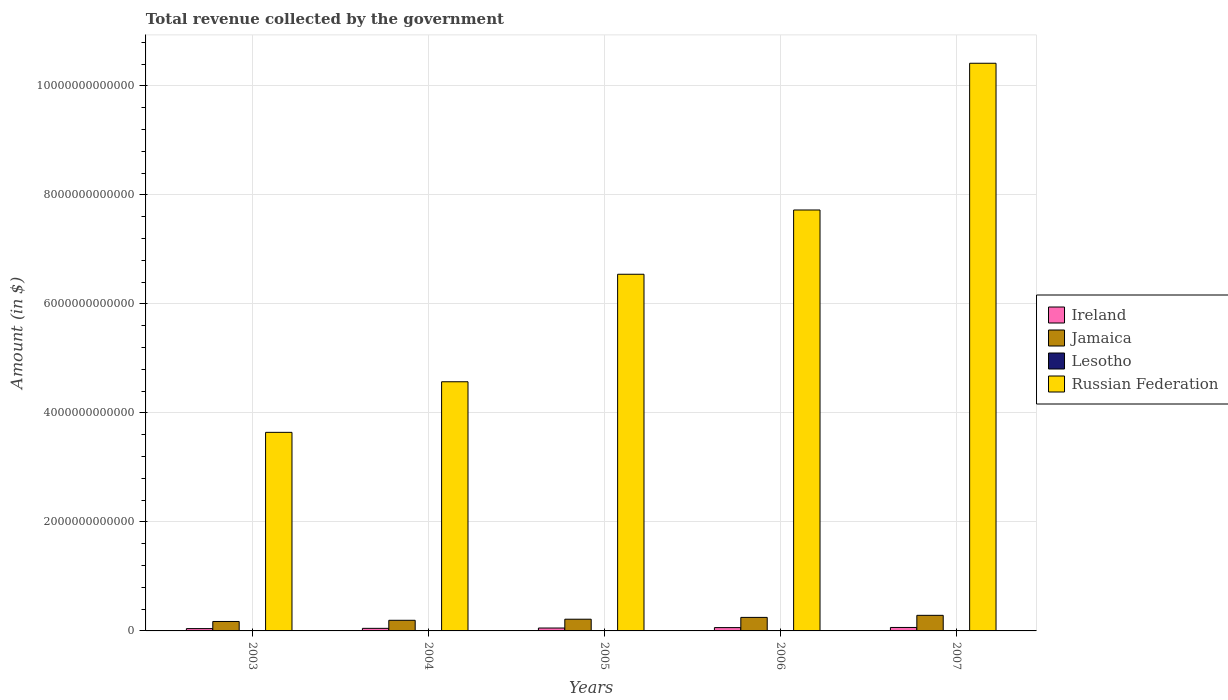How many groups of bars are there?
Your response must be concise. 5. Are the number of bars per tick equal to the number of legend labels?
Make the answer very short. Yes. How many bars are there on the 2nd tick from the left?
Offer a terse response. 4. How many bars are there on the 2nd tick from the right?
Provide a succinct answer. 4. In how many cases, is the number of bars for a given year not equal to the number of legend labels?
Offer a very short reply. 0. What is the total revenue collected by the government in Lesotho in 2003?
Make the answer very short. 3.47e+09. Across all years, what is the maximum total revenue collected by the government in Lesotho?
Ensure brevity in your answer.  7.13e+09. Across all years, what is the minimum total revenue collected by the government in Ireland?
Your answer should be compact. 4.25e+1. In which year was the total revenue collected by the government in Lesotho minimum?
Your answer should be very brief. 2003. What is the total total revenue collected by the government in Lesotho in the graph?
Provide a succinct answer. 2.59e+1. What is the difference between the total revenue collected by the government in Lesotho in 2005 and that in 2006?
Make the answer very short. -1.95e+09. What is the difference between the total revenue collected by the government in Lesotho in 2007 and the total revenue collected by the government in Jamaica in 2003?
Your answer should be compact. -1.66e+11. What is the average total revenue collected by the government in Russian Federation per year?
Make the answer very short. 6.58e+12. In the year 2006, what is the difference between the total revenue collected by the government in Jamaica and total revenue collected by the government in Russian Federation?
Provide a short and direct response. -7.48e+12. In how many years, is the total revenue collected by the government in Lesotho greater than 400000000000 $?
Keep it short and to the point. 0. What is the ratio of the total revenue collected by the government in Lesotho in 2005 to that in 2006?
Make the answer very short. 0.7. Is the difference between the total revenue collected by the government in Jamaica in 2005 and 2006 greater than the difference between the total revenue collected by the government in Russian Federation in 2005 and 2006?
Your response must be concise. Yes. What is the difference between the highest and the second highest total revenue collected by the government in Lesotho?
Offer a very short reply. 6.38e+08. What is the difference between the highest and the lowest total revenue collected by the government in Ireland?
Your response must be concise. 2.11e+1. In how many years, is the total revenue collected by the government in Jamaica greater than the average total revenue collected by the government in Jamaica taken over all years?
Your answer should be compact. 2. What does the 1st bar from the left in 2003 represents?
Offer a very short reply. Ireland. What does the 2nd bar from the right in 2005 represents?
Your answer should be very brief. Lesotho. How many bars are there?
Provide a short and direct response. 20. What is the difference between two consecutive major ticks on the Y-axis?
Give a very brief answer. 2.00e+12. Does the graph contain any zero values?
Offer a very short reply. No. Does the graph contain grids?
Your answer should be very brief. Yes. How many legend labels are there?
Provide a succinct answer. 4. What is the title of the graph?
Offer a very short reply. Total revenue collected by the government. Does "Myanmar" appear as one of the legend labels in the graph?
Offer a very short reply. No. What is the label or title of the Y-axis?
Offer a very short reply. Amount (in $). What is the Amount (in $) in Ireland in 2003?
Make the answer very short. 4.25e+1. What is the Amount (in $) in Jamaica in 2003?
Ensure brevity in your answer.  1.73e+11. What is the Amount (in $) in Lesotho in 2003?
Your response must be concise. 3.47e+09. What is the Amount (in $) of Russian Federation in 2003?
Your answer should be compact. 3.64e+12. What is the Amount (in $) of Ireland in 2004?
Your answer should be compact. 4.73e+1. What is the Amount (in $) of Jamaica in 2004?
Ensure brevity in your answer.  1.95e+11. What is the Amount (in $) in Lesotho in 2004?
Provide a short and direct response. 4.25e+09. What is the Amount (in $) of Russian Federation in 2004?
Provide a short and direct response. 4.57e+12. What is the Amount (in $) of Ireland in 2005?
Ensure brevity in your answer.  5.32e+1. What is the Amount (in $) of Jamaica in 2005?
Your answer should be very brief. 2.15e+11. What is the Amount (in $) of Lesotho in 2005?
Offer a very short reply. 4.53e+09. What is the Amount (in $) of Russian Federation in 2005?
Offer a very short reply. 6.54e+12. What is the Amount (in $) in Ireland in 2006?
Provide a succinct answer. 6.09e+1. What is the Amount (in $) of Jamaica in 2006?
Your answer should be very brief. 2.48e+11. What is the Amount (in $) in Lesotho in 2006?
Your answer should be compact. 6.49e+09. What is the Amount (in $) in Russian Federation in 2006?
Provide a succinct answer. 7.72e+12. What is the Amount (in $) in Ireland in 2007?
Keep it short and to the point. 6.36e+1. What is the Amount (in $) in Jamaica in 2007?
Make the answer very short. 2.86e+11. What is the Amount (in $) of Lesotho in 2007?
Offer a very short reply. 7.13e+09. What is the Amount (in $) of Russian Federation in 2007?
Keep it short and to the point. 1.04e+13. Across all years, what is the maximum Amount (in $) in Ireland?
Your response must be concise. 6.36e+1. Across all years, what is the maximum Amount (in $) in Jamaica?
Keep it short and to the point. 2.86e+11. Across all years, what is the maximum Amount (in $) in Lesotho?
Ensure brevity in your answer.  7.13e+09. Across all years, what is the maximum Amount (in $) of Russian Federation?
Provide a short and direct response. 1.04e+13. Across all years, what is the minimum Amount (in $) in Ireland?
Offer a very short reply. 4.25e+1. Across all years, what is the minimum Amount (in $) in Jamaica?
Give a very brief answer. 1.73e+11. Across all years, what is the minimum Amount (in $) in Lesotho?
Ensure brevity in your answer.  3.47e+09. Across all years, what is the minimum Amount (in $) in Russian Federation?
Provide a succinct answer. 3.64e+12. What is the total Amount (in $) of Ireland in the graph?
Give a very brief answer. 2.67e+11. What is the total Amount (in $) of Jamaica in the graph?
Your response must be concise. 1.12e+12. What is the total Amount (in $) in Lesotho in the graph?
Offer a terse response. 2.59e+1. What is the total Amount (in $) in Russian Federation in the graph?
Your answer should be compact. 3.29e+13. What is the difference between the Amount (in $) in Ireland in 2003 and that in 2004?
Offer a terse response. -4.79e+09. What is the difference between the Amount (in $) in Jamaica in 2003 and that in 2004?
Give a very brief answer. -2.19e+1. What is the difference between the Amount (in $) in Lesotho in 2003 and that in 2004?
Offer a terse response. -7.84e+08. What is the difference between the Amount (in $) of Russian Federation in 2003 and that in 2004?
Provide a succinct answer. -9.28e+11. What is the difference between the Amount (in $) in Ireland in 2003 and that in 2005?
Provide a succinct answer. -1.07e+1. What is the difference between the Amount (in $) in Jamaica in 2003 and that in 2005?
Your response must be concise. -4.17e+1. What is the difference between the Amount (in $) in Lesotho in 2003 and that in 2005?
Your response must be concise. -1.07e+09. What is the difference between the Amount (in $) of Russian Federation in 2003 and that in 2005?
Offer a terse response. -2.90e+12. What is the difference between the Amount (in $) in Ireland in 2003 and that in 2006?
Offer a very short reply. -1.84e+1. What is the difference between the Amount (in $) of Jamaica in 2003 and that in 2006?
Offer a very short reply. -7.50e+1. What is the difference between the Amount (in $) in Lesotho in 2003 and that in 2006?
Make the answer very short. -3.02e+09. What is the difference between the Amount (in $) in Russian Federation in 2003 and that in 2006?
Give a very brief answer. -4.08e+12. What is the difference between the Amount (in $) in Ireland in 2003 and that in 2007?
Your answer should be very brief. -2.11e+1. What is the difference between the Amount (in $) of Jamaica in 2003 and that in 2007?
Ensure brevity in your answer.  -1.13e+11. What is the difference between the Amount (in $) of Lesotho in 2003 and that in 2007?
Provide a succinct answer. -3.66e+09. What is the difference between the Amount (in $) of Russian Federation in 2003 and that in 2007?
Give a very brief answer. -6.77e+12. What is the difference between the Amount (in $) of Ireland in 2004 and that in 2005?
Ensure brevity in your answer.  -5.94e+09. What is the difference between the Amount (in $) of Jamaica in 2004 and that in 2005?
Provide a succinct answer. -1.99e+1. What is the difference between the Amount (in $) of Lesotho in 2004 and that in 2005?
Offer a terse response. -2.81e+08. What is the difference between the Amount (in $) in Russian Federation in 2004 and that in 2005?
Offer a terse response. -1.97e+12. What is the difference between the Amount (in $) of Ireland in 2004 and that in 2006?
Provide a short and direct response. -1.36e+1. What is the difference between the Amount (in $) in Jamaica in 2004 and that in 2006?
Your answer should be very brief. -5.32e+1. What is the difference between the Amount (in $) in Lesotho in 2004 and that in 2006?
Your answer should be compact. -2.23e+09. What is the difference between the Amount (in $) in Russian Federation in 2004 and that in 2006?
Provide a succinct answer. -3.15e+12. What is the difference between the Amount (in $) in Ireland in 2004 and that in 2007?
Provide a short and direct response. -1.63e+1. What is the difference between the Amount (in $) of Jamaica in 2004 and that in 2007?
Your response must be concise. -9.10e+1. What is the difference between the Amount (in $) of Lesotho in 2004 and that in 2007?
Make the answer very short. -2.87e+09. What is the difference between the Amount (in $) of Russian Federation in 2004 and that in 2007?
Give a very brief answer. -5.84e+12. What is the difference between the Amount (in $) in Ireland in 2005 and that in 2006?
Ensure brevity in your answer.  -7.67e+09. What is the difference between the Amount (in $) in Jamaica in 2005 and that in 2006?
Offer a very short reply. -3.33e+1. What is the difference between the Amount (in $) of Lesotho in 2005 and that in 2006?
Your response must be concise. -1.95e+09. What is the difference between the Amount (in $) in Russian Federation in 2005 and that in 2006?
Provide a short and direct response. -1.18e+12. What is the difference between the Amount (in $) of Ireland in 2005 and that in 2007?
Offer a very short reply. -1.04e+1. What is the difference between the Amount (in $) in Jamaica in 2005 and that in 2007?
Ensure brevity in your answer.  -7.11e+1. What is the difference between the Amount (in $) in Lesotho in 2005 and that in 2007?
Provide a short and direct response. -2.59e+09. What is the difference between the Amount (in $) in Russian Federation in 2005 and that in 2007?
Give a very brief answer. -3.87e+12. What is the difference between the Amount (in $) of Ireland in 2006 and that in 2007?
Your response must be concise. -2.70e+09. What is the difference between the Amount (in $) in Jamaica in 2006 and that in 2007?
Keep it short and to the point. -3.78e+1. What is the difference between the Amount (in $) in Lesotho in 2006 and that in 2007?
Make the answer very short. -6.38e+08. What is the difference between the Amount (in $) in Russian Federation in 2006 and that in 2007?
Your answer should be compact. -2.69e+12. What is the difference between the Amount (in $) of Ireland in 2003 and the Amount (in $) of Jamaica in 2004?
Offer a terse response. -1.53e+11. What is the difference between the Amount (in $) in Ireland in 2003 and the Amount (in $) in Lesotho in 2004?
Offer a very short reply. 3.82e+1. What is the difference between the Amount (in $) of Ireland in 2003 and the Amount (in $) of Russian Federation in 2004?
Make the answer very short. -4.53e+12. What is the difference between the Amount (in $) of Jamaica in 2003 and the Amount (in $) of Lesotho in 2004?
Your answer should be compact. 1.69e+11. What is the difference between the Amount (in $) in Jamaica in 2003 and the Amount (in $) in Russian Federation in 2004?
Keep it short and to the point. -4.40e+12. What is the difference between the Amount (in $) in Lesotho in 2003 and the Amount (in $) in Russian Federation in 2004?
Give a very brief answer. -4.57e+12. What is the difference between the Amount (in $) in Ireland in 2003 and the Amount (in $) in Jamaica in 2005?
Your response must be concise. -1.72e+11. What is the difference between the Amount (in $) of Ireland in 2003 and the Amount (in $) of Lesotho in 2005?
Keep it short and to the point. 3.79e+1. What is the difference between the Amount (in $) in Ireland in 2003 and the Amount (in $) in Russian Federation in 2005?
Give a very brief answer. -6.50e+12. What is the difference between the Amount (in $) in Jamaica in 2003 and the Amount (in $) in Lesotho in 2005?
Provide a succinct answer. 1.69e+11. What is the difference between the Amount (in $) in Jamaica in 2003 and the Amount (in $) in Russian Federation in 2005?
Your answer should be very brief. -6.37e+12. What is the difference between the Amount (in $) of Lesotho in 2003 and the Amount (in $) of Russian Federation in 2005?
Provide a short and direct response. -6.54e+12. What is the difference between the Amount (in $) of Ireland in 2003 and the Amount (in $) of Jamaica in 2006?
Provide a short and direct response. -2.06e+11. What is the difference between the Amount (in $) of Ireland in 2003 and the Amount (in $) of Lesotho in 2006?
Give a very brief answer. 3.60e+1. What is the difference between the Amount (in $) in Ireland in 2003 and the Amount (in $) in Russian Federation in 2006?
Your answer should be very brief. -7.68e+12. What is the difference between the Amount (in $) in Jamaica in 2003 and the Amount (in $) in Lesotho in 2006?
Give a very brief answer. 1.67e+11. What is the difference between the Amount (in $) in Jamaica in 2003 and the Amount (in $) in Russian Federation in 2006?
Provide a succinct answer. -7.55e+12. What is the difference between the Amount (in $) of Lesotho in 2003 and the Amount (in $) of Russian Federation in 2006?
Make the answer very short. -7.72e+12. What is the difference between the Amount (in $) in Ireland in 2003 and the Amount (in $) in Jamaica in 2007?
Your answer should be very brief. -2.44e+11. What is the difference between the Amount (in $) in Ireland in 2003 and the Amount (in $) in Lesotho in 2007?
Give a very brief answer. 3.53e+1. What is the difference between the Amount (in $) in Ireland in 2003 and the Amount (in $) in Russian Federation in 2007?
Offer a very short reply. -1.04e+13. What is the difference between the Amount (in $) in Jamaica in 2003 and the Amount (in $) in Lesotho in 2007?
Provide a short and direct response. 1.66e+11. What is the difference between the Amount (in $) in Jamaica in 2003 and the Amount (in $) in Russian Federation in 2007?
Provide a succinct answer. -1.02e+13. What is the difference between the Amount (in $) of Lesotho in 2003 and the Amount (in $) of Russian Federation in 2007?
Your answer should be very brief. -1.04e+13. What is the difference between the Amount (in $) in Ireland in 2004 and the Amount (in $) in Jamaica in 2005?
Provide a short and direct response. -1.68e+11. What is the difference between the Amount (in $) in Ireland in 2004 and the Amount (in $) in Lesotho in 2005?
Provide a short and direct response. 4.27e+1. What is the difference between the Amount (in $) of Ireland in 2004 and the Amount (in $) of Russian Federation in 2005?
Make the answer very short. -6.50e+12. What is the difference between the Amount (in $) in Jamaica in 2004 and the Amount (in $) in Lesotho in 2005?
Provide a short and direct response. 1.91e+11. What is the difference between the Amount (in $) of Jamaica in 2004 and the Amount (in $) of Russian Federation in 2005?
Your answer should be compact. -6.35e+12. What is the difference between the Amount (in $) in Lesotho in 2004 and the Amount (in $) in Russian Federation in 2005?
Offer a terse response. -6.54e+12. What is the difference between the Amount (in $) in Ireland in 2004 and the Amount (in $) in Jamaica in 2006?
Give a very brief answer. -2.01e+11. What is the difference between the Amount (in $) of Ireland in 2004 and the Amount (in $) of Lesotho in 2006?
Your answer should be compact. 4.08e+1. What is the difference between the Amount (in $) of Ireland in 2004 and the Amount (in $) of Russian Federation in 2006?
Make the answer very short. -7.68e+12. What is the difference between the Amount (in $) in Jamaica in 2004 and the Amount (in $) in Lesotho in 2006?
Provide a succinct answer. 1.89e+11. What is the difference between the Amount (in $) in Jamaica in 2004 and the Amount (in $) in Russian Federation in 2006?
Ensure brevity in your answer.  -7.53e+12. What is the difference between the Amount (in $) of Lesotho in 2004 and the Amount (in $) of Russian Federation in 2006?
Provide a short and direct response. -7.72e+12. What is the difference between the Amount (in $) of Ireland in 2004 and the Amount (in $) of Jamaica in 2007?
Keep it short and to the point. -2.39e+11. What is the difference between the Amount (in $) of Ireland in 2004 and the Amount (in $) of Lesotho in 2007?
Provide a succinct answer. 4.01e+1. What is the difference between the Amount (in $) of Ireland in 2004 and the Amount (in $) of Russian Federation in 2007?
Ensure brevity in your answer.  -1.04e+13. What is the difference between the Amount (in $) of Jamaica in 2004 and the Amount (in $) of Lesotho in 2007?
Provide a succinct answer. 1.88e+11. What is the difference between the Amount (in $) of Jamaica in 2004 and the Amount (in $) of Russian Federation in 2007?
Give a very brief answer. -1.02e+13. What is the difference between the Amount (in $) of Lesotho in 2004 and the Amount (in $) of Russian Federation in 2007?
Offer a very short reply. -1.04e+13. What is the difference between the Amount (in $) in Ireland in 2005 and the Amount (in $) in Jamaica in 2006?
Provide a short and direct response. -1.95e+11. What is the difference between the Amount (in $) in Ireland in 2005 and the Amount (in $) in Lesotho in 2006?
Your response must be concise. 4.67e+1. What is the difference between the Amount (in $) of Ireland in 2005 and the Amount (in $) of Russian Federation in 2006?
Provide a short and direct response. -7.67e+12. What is the difference between the Amount (in $) in Jamaica in 2005 and the Amount (in $) in Lesotho in 2006?
Provide a short and direct response. 2.08e+11. What is the difference between the Amount (in $) of Jamaica in 2005 and the Amount (in $) of Russian Federation in 2006?
Provide a short and direct response. -7.51e+12. What is the difference between the Amount (in $) in Lesotho in 2005 and the Amount (in $) in Russian Federation in 2006?
Your answer should be very brief. -7.72e+12. What is the difference between the Amount (in $) of Ireland in 2005 and the Amount (in $) of Jamaica in 2007?
Offer a terse response. -2.33e+11. What is the difference between the Amount (in $) in Ireland in 2005 and the Amount (in $) in Lesotho in 2007?
Give a very brief answer. 4.61e+1. What is the difference between the Amount (in $) of Ireland in 2005 and the Amount (in $) of Russian Federation in 2007?
Your response must be concise. -1.04e+13. What is the difference between the Amount (in $) in Jamaica in 2005 and the Amount (in $) in Lesotho in 2007?
Your answer should be very brief. 2.08e+11. What is the difference between the Amount (in $) in Jamaica in 2005 and the Amount (in $) in Russian Federation in 2007?
Provide a succinct answer. -1.02e+13. What is the difference between the Amount (in $) of Lesotho in 2005 and the Amount (in $) of Russian Federation in 2007?
Provide a short and direct response. -1.04e+13. What is the difference between the Amount (in $) in Ireland in 2006 and the Amount (in $) in Jamaica in 2007?
Your answer should be very brief. -2.25e+11. What is the difference between the Amount (in $) in Ireland in 2006 and the Amount (in $) in Lesotho in 2007?
Provide a succinct answer. 5.37e+1. What is the difference between the Amount (in $) of Ireland in 2006 and the Amount (in $) of Russian Federation in 2007?
Ensure brevity in your answer.  -1.04e+13. What is the difference between the Amount (in $) of Jamaica in 2006 and the Amount (in $) of Lesotho in 2007?
Offer a very short reply. 2.41e+11. What is the difference between the Amount (in $) of Jamaica in 2006 and the Amount (in $) of Russian Federation in 2007?
Make the answer very short. -1.02e+13. What is the difference between the Amount (in $) of Lesotho in 2006 and the Amount (in $) of Russian Federation in 2007?
Offer a terse response. -1.04e+13. What is the average Amount (in $) of Ireland per year?
Offer a terse response. 5.35e+1. What is the average Amount (in $) in Jamaica per year?
Provide a succinct answer. 2.23e+11. What is the average Amount (in $) in Lesotho per year?
Offer a very short reply. 5.17e+09. What is the average Amount (in $) of Russian Federation per year?
Give a very brief answer. 6.58e+12. In the year 2003, what is the difference between the Amount (in $) in Ireland and Amount (in $) in Jamaica?
Make the answer very short. -1.31e+11. In the year 2003, what is the difference between the Amount (in $) in Ireland and Amount (in $) in Lesotho?
Provide a succinct answer. 3.90e+1. In the year 2003, what is the difference between the Amount (in $) of Ireland and Amount (in $) of Russian Federation?
Offer a terse response. -3.60e+12. In the year 2003, what is the difference between the Amount (in $) of Jamaica and Amount (in $) of Lesotho?
Your answer should be very brief. 1.70e+11. In the year 2003, what is the difference between the Amount (in $) of Jamaica and Amount (in $) of Russian Federation?
Provide a short and direct response. -3.47e+12. In the year 2003, what is the difference between the Amount (in $) in Lesotho and Amount (in $) in Russian Federation?
Provide a succinct answer. -3.64e+12. In the year 2004, what is the difference between the Amount (in $) in Ireland and Amount (in $) in Jamaica?
Make the answer very short. -1.48e+11. In the year 2004, what is the difference between the Amount (in $) in Ireland and Amount (in $) in Lesotho?
Give a very brief answer. 4.30e+1. In the year 2004, what is the difference between the Amount (in $) in Ireland and Amount (in $) in Russian Federation?
Give a very brief answer. -4.52e+12. In the year 2004, what is the difference between the Amount (in $) in Jamaica and Amount (in $) in Lesotho?
Ensure brevity in your answer.  1.91e+11. In the year 2004, what is the difference between the Amount (in $) in Jamaica and Amount (in $) in Russian Federation?
Offer a very short reply. -4.38e+12. In the year 2004, what is the difference between the Amount (in $) of Lesotho and Amount (in $) of Russian Federation?
Your response must be concise. -4.57e+12. In the year 2005, what is the difference between the Amount (in $) of Ireland and Amount (in $) of Jamaica?
Your answer should be very brief. -1.62e+11. In the year 2005, what is the difference between the Amount (in $) in Ireland and Amount (in $) in Lesotho?
Provide a short and direct response. 4.87e+1. In the year 2005, what is the difference between the Amount (in $) in Ireland and Amount (in $) in Russian Federation?
Your response must be concise. -6.49e+12. In the year 2005, what is the difference between the Amount (in $) of Jamaica and Amount (in $) of Lesotho?
Make the answer very short. 2.10e+11. In the year 2005, what is the difference between the Amount (in $) in Jamaica and Amount (in $) in Russian Federation?
Your answer should be compact. -6.33e+12. In the year 2005, what is the difference between the Amount (in $) of Lesotho and Amount (in $) of Russian Federation?
Offer a terse response. -6.54e+12. In the year 2006, what is the difference between the Amount (in $) in Ireland and Amount (in $) in Jamaica?
Ensure brevity in your answer.  -1.87e+11. In the year 2006, what is the difference between the Amount (in $) in Ireland and Amount (in $) in Lesotho?
Keep it short and to the point. 5.44e+1. In the year 2006, what is the difference between the Amount (in $) in Ireland and Amount (in $) in Russian Federation?
Your response must be concise. -7.66e+12. In the year 2006, what is the difference between the Amount (in $) of Jamaica and Amount (in $) of Lesotho?
Offer a very short reply. 2.42e+11. In the year 2006, what is the difference between the Amount (in $) of Jamaica and Amount (in $) of Russian Federation?
Offer a very short reply. -7.48e+12. In the year 2006, what is the difference between the Amount (in $) of Lesotho and Amount (in $) of Russian Federation?
Keep it short and to the point. -7.72e+12. In the year 2007, what is the difference between the Amount (in $) of Ireland and Amount (in $) of Jamaica?
Your answer should be very brief. -2.22e+11. In the year 2007, what is the difference between the Amount (in $) in Ireland and Amount (in $) in Lesotho?
Your answer should be compact. 5.64e+1. In the year 2007, what is the difference between the Amount (in $) of Ireland and Amount (in $) of Russian Federation?
Make the answer very short. -1.04e+13. In the year 2007, what is the difference between the Amount (in $) in Jamaica and Amount (in $) in Lesotho?
Your answer should be compact. 2.79e+11. In the year 2007, what is the difference between the Amount (in $) of Jamaica and Amount (in $) of Russian Federation?
Your answer should be very brief. -1.01e+13. In the year 2007, what is the difference between the Amount (in $) in Lesotho and Amount (in $) in Russian Federation?
Your answer should be compact. -1.04e+13. What is the ratio of the Amount (in $) in Ireland in 2003 to that in 2004?
Offer a very short reply. 0.9. What is the ratio of the Amount (in $) in Jamaica in 2003 to that in 2004?
Provide a short and direct response. 0.89. What is the ratio of the Amount (in $) of Lesotho in 2003 to that in 2004?
Keep it short and to the point. 0.82. What is the ratio of the Amount (in $) of Russian Federation in 2003 to that in 2004?
Make the answer very short. 0.8. What is the ratio of the Amount (in $) of Ireland in 2003 to that in 2005?
Offer a very short reply. 0.8. What is the ratio of the Amount (in $) in Jamaica in 2003 to that in 2005?
Keep it short and to the point. 0.81. What is the ratio of the Amount (in $) in Lesotho in 2003 to that in 2005?
Your response must be concise. 0.77. What is the ratio of the Amount (in $) of Russian Federation in 2003 to that in 2005?
Your answer should be compact. 0.56. What is the ratio of the Amount (in $) in Ireland in 2003 to that in 2006?
Ensure brevity in your answer.  0.7. What is the ratio of the Amount (in $) in Jamaica in 2003 to that in 2006?
Your answer should be compact. 0.7. What is the ratio of the Amount (in $) of Lesotho in 2003 to that in 2006?
Give a very brief answer. 0.53. What is the ratio of the Amount (in $) of Russian Federation in 2003 to that in 2006?
Keep it short and to the point. 0.47. What is the ratio of the Amount (in $) in Ireland in 2003 to that in 2007?
Provide a short and direct response. 0.67. What is the ratio of the Amount (in $) of Jamaica in 2003 to that in 2007?
Your response must be concise. 0.61. What is the ratio of the Amount (in $) in Lesotho in 2003 to that in 2007?
Offer a terse response. 0.49. What is the ratio of the Amount (in $) in Russian Federation in 2003 to that in 2007?
Offer a very short reply. 0.35. What is the ratio of the Amount (in $) in Ireland in 2004 to that in 2005?
Keep it short and to the point. 0.89. What is the ratio of the Amount (in $) of Jamaica in 2004 to that in 2005?
Your answer should be compact. 0.91. What is the ratio of the Amount (in $) in Lesotho in 2004 to that in 2005?
Offer a terse response. 0.94. What is the ratio of the Amount (in $) in Russian Federation in 2004 to that in 2005?
Offer a very short reply. 0.7. What is the ratio of the Amount (in $) in Ireland in 2004 to that in 2006?
Ensure brevity in your answer.  0.78. What is the ratio of the Amount (in $) in Jamaica in 2004 to that in 2006?
Offer a terse response. 0.79. What is the ratio of the Amount (in $) of Lesotho in 2004 to that in 2006?
Give a very brief answer. 0.66. What is the ratio of the Amount (in $) in Russian Federation in 2004 to that in 2006?
Keep it short and to the point. 0.59. What is the ratio of the Amount (in $) of Ireland in 2004 to that in 2007?
Keep it short and to the point. 0.74. What is the ratio of the Amount (in $) of Jamaica in 2004 to that in 2007?
Offer a very short reply. 0.68. What is the ratio of the Amount (in $) of Lesotho in 2004 to that in 2007?
Your answer should be very brief. 0.6. What is the ratio of the Amount (in $) of Russian Federation in 2004 to that in 2007?
Your answer should be compact. 0.44. What is the ratio of the Amount (in $) of Ireland in 2005 to that in 2006?
Give a very brief answer. 0.87. What is the ratio of the Amount (in $) of Jamaica in 2005 to that in 2006?
Provide a short and direct response. 0.87. What is the ratio of the Amount (in $) of Lesotho in 2005 to that in 2006?
Give a very brief answer. 0.7. What is the ratio of the Amount (in $) in Russian Federation in 2005 to that in 2006?
Your answer should be compact. 0.85. What is the ratio of the Amount (in $) in Ireland in 2005 to that in 2007?
Your response must be concise. 0.84. What is the ratio of the Amount (in $) in Jamaica in 2005 to that in 2007?
Offer a terse response. 0.75. What is the ratio of the Amount (in $) of Lesotho in 2005 to that in 2007?
Offer a terse response. 0.64. What is the ratio of the Amount (in $) in Russian Federation in 2005 to that in 2007?
Provide a short and direct response. 0.63. What is the ratio of the Amount (in $) of Ireland in 2006 to that in 2007?
Offer a very short reply. 0.96. What is the ratio of the Amount (in $) in Jamaica in 2006 to that in 2007?
Your response must be concise. 0.87. What is the ratio of the Amount (in $) in Lesotho in 2006 to that in 2007?
Provide a short and direct response. 0.91. What is the ratio of the Amount (in $) of Russian Federation in 2006 to that in 2007?
Provide a succinct answer. 0.74. What is the difference between the highest and the second highest Amount (in $) of Ireland?
Your response must be concise. 2.70e+09. What is the difference between the highest and the second highest Amount (in $) in Jamaica?
Your answer should be very brief. 3.78e+1. What is the difference between the highest and the second highest Amount (in $) in Lesotho?
Ensure brevity in your answer.  6.38e+08. What is the difference between the highest and the second highest Amount (in $) in Russian Federation?
Your answer should be very brief. 2.69e+12. What is the difference between the highest and the lowest Amount (in $) of Ireland?
Give a very brief answer. 2.11e+1. What is the difference between the highest and the lowest Amount (in $) in Jamaica?
Provide a succinct answer. 1.13e+11. What is the difference between the highest and the lowest Amount (in $) in Lesotho?
Provide a short and direct response. 3.66e+09. What is the difference between the highest and the lowest Amount (in $) of Russian Federation?
Provide a succinct answer. 6.77e+12. 